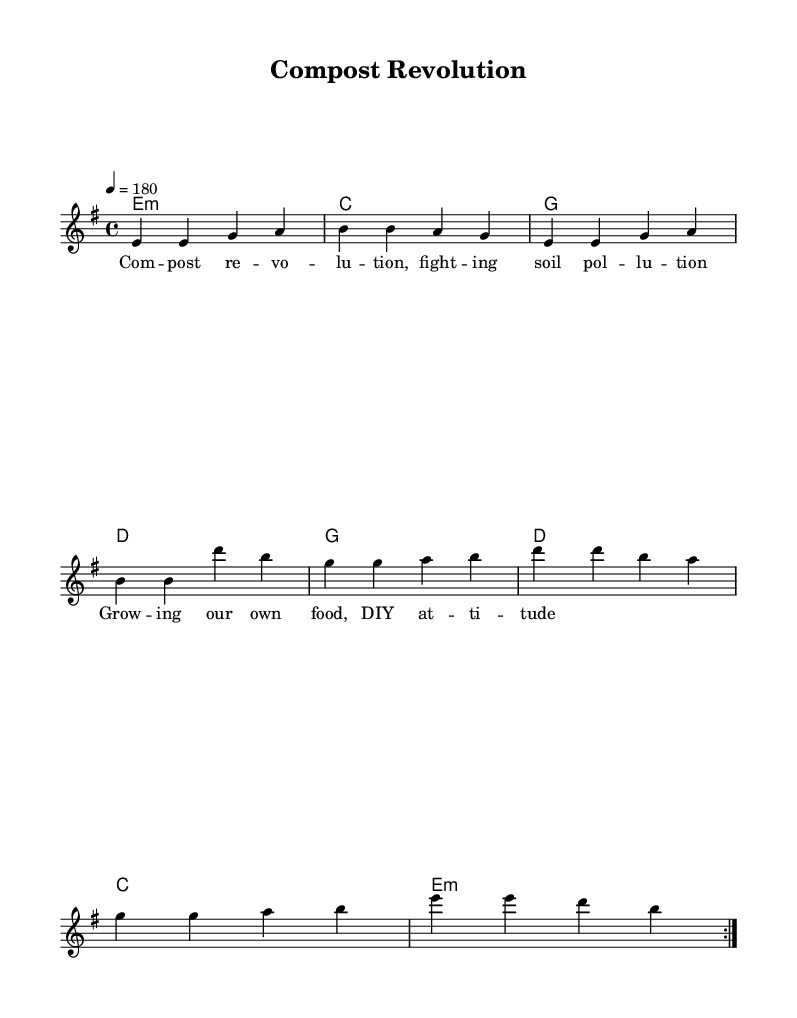What is the key signature of this music? The music is in E minor, which has one sharp (F#). This can be inferred from the key indicated in the global settings of the LilyPond code.
Answer: E minor What is the time signature of this music? The time signature is 4/4, as stated in the global settings. This means there are four beats in each measure, and a quarter note receives one beat.
Answer: 4/4 What is the tempo marking for the piece? The tempo marking is 180 beats per minute, specified by the "tempo" directive in the code. This indicates how fast the piece should be played.
Answer: 180 How many measures are in the main melody? The melody contains sixteen measures, determined by counting the individual measures in the repeated sections of the melody. The code shows a repeat symbol indicating that the melody is played twice.
Answer: sixteen How many times is the chord in E minor played? The chord in E minor is played twice, as indicated in the harmonies section where "e1:m" is repeated in the structure of the chord progression.
Answer: twice What is the theme of the lyrics? The theme of the lyrics revolves around composting and fighting soil pollution, which connects directly to the title "Compost Revolution" and the focus on sustainable practices.
Answer: composting and soil pollution What is the overall mood suggested by the tempo and lyrics? The overall mood is energetic and assertive, suggested by the fast tempo of 180 and the evocative call to action in the lyrics about fighting pollution and promoting DIY attitudes.
Answer: energetic and assertive 